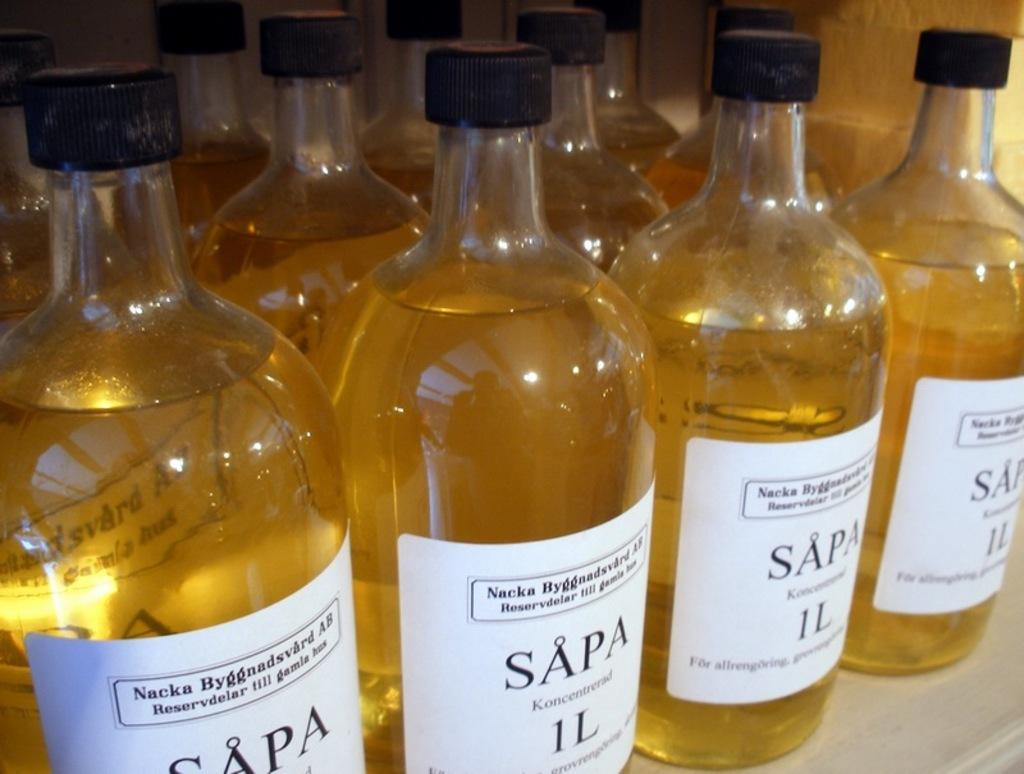<image>
Write a terse but informative summary of the picture. the word Sapa that is on some beer bottles 